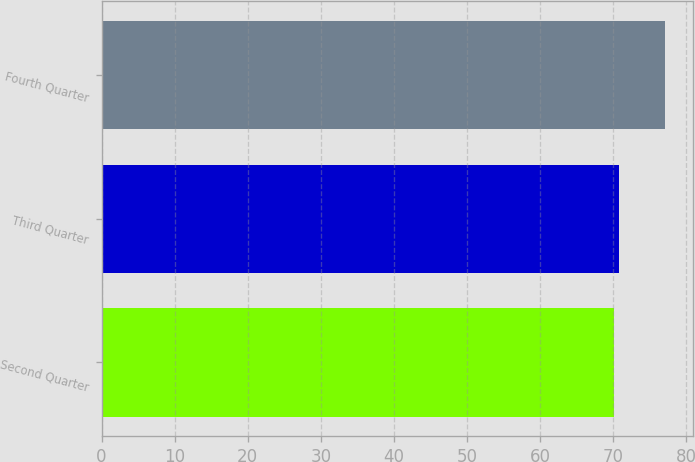<chart> <loc_0><loc_0><loc_500><loc_500><bar_chart><fcel>Second Quarter<fcel>Third Quarter<fcel>Fourth Quarter<nl><fcel>70.07<fcel>70.78<fcel>77.14<nl></chart> 